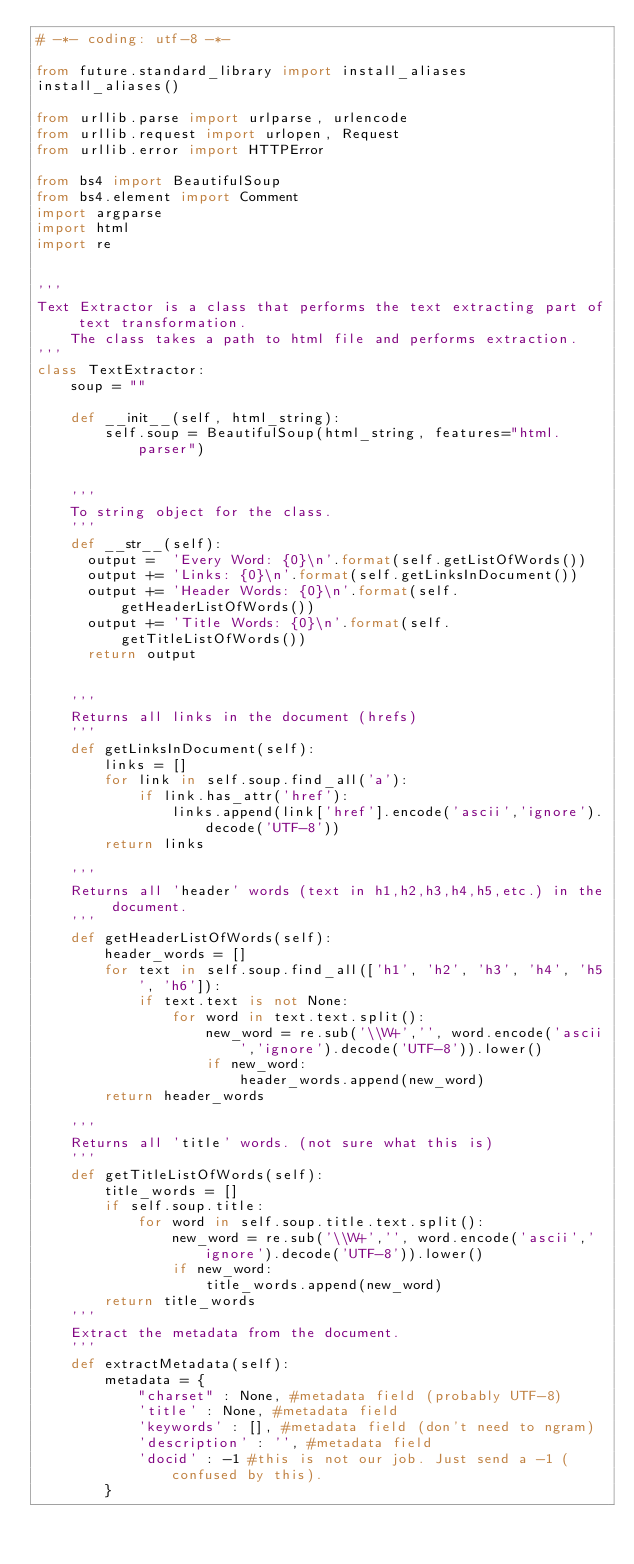<code> <loc_0><loc_0><loc_500><loc_500><_Python_># -*- coding: utf-8 -*- 

from future.standard_library import install_aliases
install_aliases()

from urllib.parse import urlparse, urlencode
from urllib.request import urlopen, Request
from urllib.error import HTTPError

from bs4 import BeautifulSoup
from bs4.element import Comment
import argparse
import html
import re


'''
Text Extractor is a class that performs the text extracting part of text transformation.
    The class takes a path to html file and performs extraction.
'''
class TextExtractor:
    soup = ""

    def __init__(self, html_string):
        self.soup = BeautifulSoup(html_string, features="html.parser")


    '''
    To string object for the class.
    '''
    def __str__(self):
      output =  'Every Word: {0}\n'.format(self.getListOfWords())
      output += 'Links: {0}\n'.format(self.getLinksInDocument())
      output += 'Header Words: {0}\n'.format(self.getHeaderListOfWords())
      output += 'Title Words: {0}\n'.format(self.getTitleListOfWords())
      return output


    '''
    Returns all links in the document (hrefs)
    '''
    def getLinksInDocument(self):
        links = []
        for link in self.soup.find_all('a'):
            if link.has_attr('href'):
                links.append(link['href'].encode('ascii','ignore').decode('UTF-8'))
        return links

    '''
    Returns all 'header' words (text in h1,h2,h3,h4,h5,etc.) in the document.
    '''
    def getHeaderListOfWords(self):
        header_words = []
        for text in self.soup.find_all(['h1', 'h2', 'h3', 'h4', 'h5', 'h6']):
            if text.text is not None:
                for word in text.text.split():
                    new_word = re.sub('\\W+','', word.encode('ascii','ignore').decode('UTF-8')).lower()
                    if new_word:
                        header_words.append(new_word)
        return header_words

    '''
    Returns all 'title' words. (not sure what this is)
    '''
    def getTitleListOfWords(self):
        title_words = []
        if self.soup.title:
            for word in self.soup.title.text.split():
                new_word = re.sub('\\W+','', word.encode('ascii','ignore').decode('UTF-8')).lower()
                if new_word:
                    title_words.append(new_word)
        return title_words
    '''
    Extract the metadata from the document.
    '''
    def extractMetadata(self):
        metadata = {
            "charset" : None, #metadata field (probably UTF-8)
            'title' : None, #metadata field
            'keywords' : [], #metadata field (don't need to ngram)
            'description' : '', #metadata field
            'docid' : -1 #this is not our job. Just send a -1 (confused by this).
        }</code> 